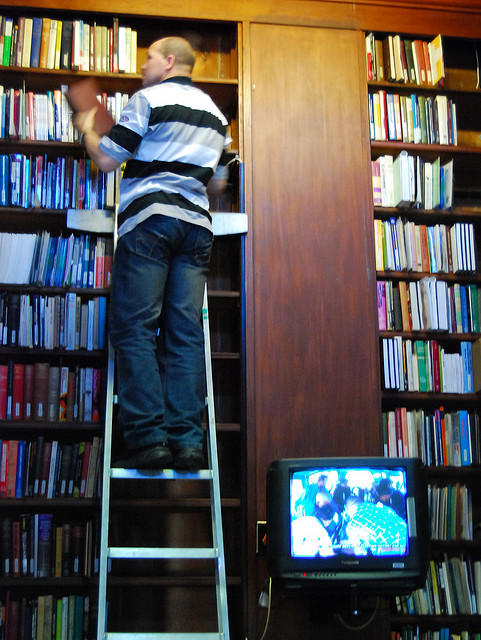Could the inclusion of technology, like that seen on the TV in the image, play a role in enhancing the accessibility of books in high shelves? Indeed, technology such as digital catalogs displayed on screens, similar to the TV seen in the image, could guide visitors to locate books easily without the physical need to search through high shelves. Additionally, implementing electronic retrieval systems could allow visitors to request books stored out of reach, thereby improving accessibility and reducing the physical strain. 